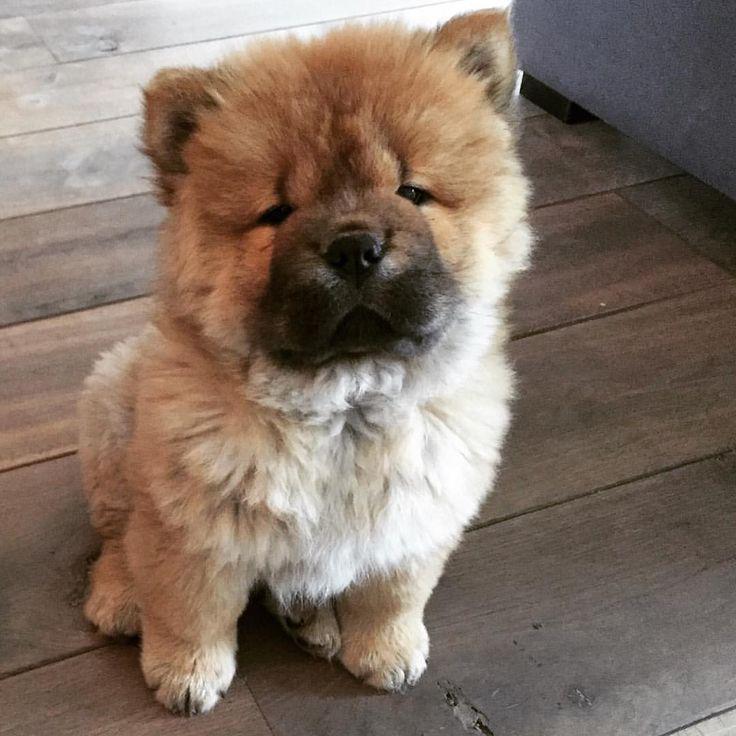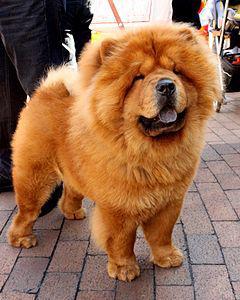The first image is the image on the left, the second image is the image on the right. Evaluate the accuracy of this statement regarding the images: "All four dogs are standing up.". Is it true? Answer yes or no. No. 